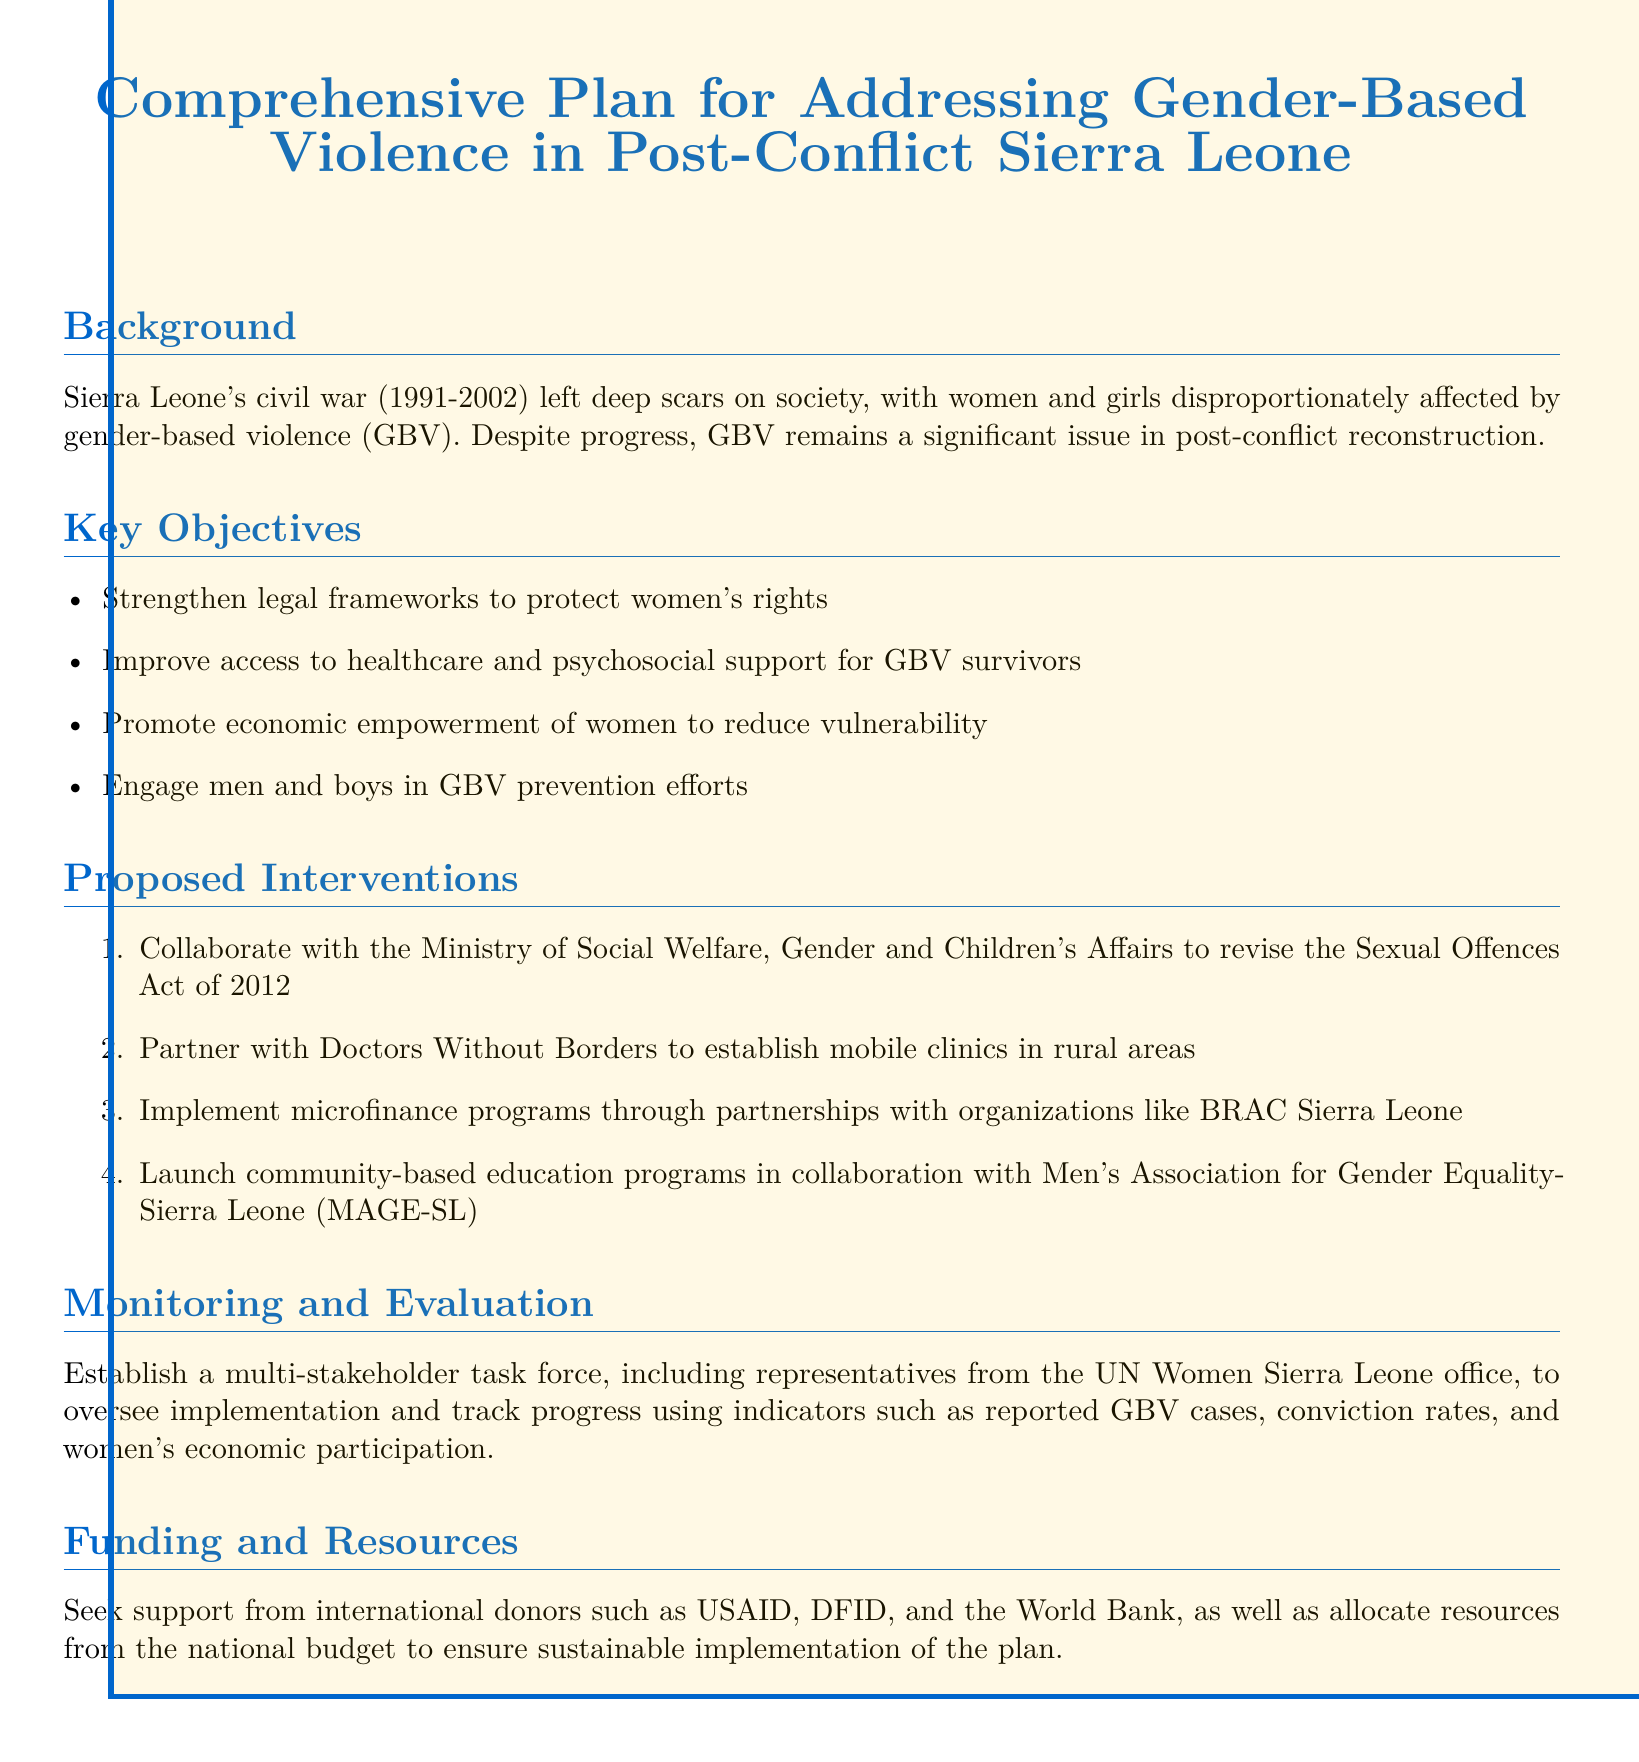What is the duration of Sierra Leone's civil war? The document states that the civil war lasted from 1991 to 2002, which totals 11 years.
Answer: 11 years What is one key objective of the comprehensive plan? The document lists several key objectives for the plan, including strengthening legal frameworks.
Answer: Strengthen legal frameworks Which organization is mentioned as a partner for establishing mobile clinics? The text refers to a collaboration with Doctors Without Borders for establishing mobile clinics.
Answer: Doctors Without Borders How many proposed interventions are outlined in the document? The document enumerates four specific interventions proposed to address GBV.
Answer: Four Who is involved in overseeing the implementation of the plan? The document specifies the establishment of a multi-stakeholder task force, including representatives from UN Women Sierra Leone.
Answer: UN Women Sierra Leone What is a proposed method to reduce women's vulnerability? The document mentions promoting economic empowerment as a strategy to reduce vulnerability.
Answer: Economic empowerment Which legislation is targeted for revision in the interventions? The document refers to the revision of the Sexual Offences Act of 2012 as part of the proposed interventions.
Answer: Sexual Offences Act of 2012 What type of programs are to be implemented through partnerships with BRAC Sierra Leone? The document discusses implementing microfinance programs to aid women.
Answer: Microfinance programs Which stakeholders are suggested for funding support? The document mentions seeking support from international donors such as USAID, DFID, and the World Bank.
Answer: USAID, DFID, World Bank 